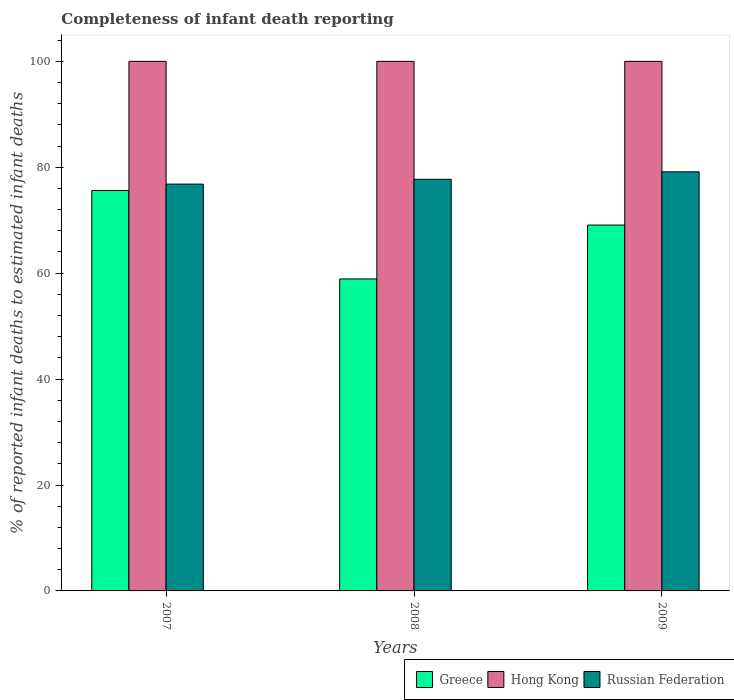How many different coloured bars are there?
Offer a very short reply. 3. What is the label of the 2nd group of bars from the left?
Give a very brief answer. 2008. Across all years, what is the maximum percentage of infant deaths reported in Russian Federation?
Give a very brief answer. 79.14. Across all years, what is the minimum percentage of infant deaths reported in Greece?
Your response must be concise. 58.91. In which year was the percentage of infant deaths reported in Hong Kong maximum?
Make the answer very short. 2007. In which year was the percentage of infant deaths reported in Greece minimum?
Make the answer very short. 2008. What is the total percentage of infant deaths reported in Greece in the graph?
Keep it short and to the point. 203.62. What is the difference between the percentage of infant deaths reported in Russian Federation in 2008 and the percentage of infant deaths reported in Hong Kong in 2009?
Make the answer very short. -22.27. In the year 2009, what is the difference between the percentage of infant deaths reported in Greece and percentage of infant deaths reported in Russian Federation?
Make the answer very short. -10.06. What is the ratio of the percentage of infant deaths reported in Hong Kong in 2007 to that in 2008?
Give a very brief answer. 1. What is the difference between the highest and the second highest percentage of infant deaths reported in Russian Federation?
Give a very brief answer. 1.41. What does the 3rd bar from the left in 2008 represents?
Offer a terse response. Russian Federation. What does the 2nd bar from the right in 2009 represents?
Keep it short and to the point. Hong Kong. How many bars are there?
Your answer should be compact. 9. Are all the bars in the graph horizontal?
Make the answer very short. No. Are the values on the major ticks of Y-axis written in scientific E-notation?
Give a very brief answer. No. Does the graph contain any zero values?
Offer a terse response. No. Does the graph contain grids?
Provide a short and direct response. No. How many legend labels are there?
Your answer should be compact. 3. What is the title of the graph?
Your response must be concise. Completeness of infant death reporting. What is the label or title of the X-axis?
Your answer should be very brief. Years. What is the label or title of the Y-axis?
Make the answer very short. % of reported infant deaths to estimated infant deaths. What is the % of reported infant deaths to estimated infant deaths in Greece in 2007?
Your response must be concise. 75.62. What is the % of reported infant deaths to estimated infant deaths in Russian Federation in 2007?
Keep it short and to the point. 76.82. What is the % of reported infant deaths to estimated infant deaths in Greece in 2008?
Ensure brevity in your answer.  58.91. What is the % of reported infant deaths to estimated infant deaths in Russian Federation in 2008?
Make the answer very short. 77.73. What is the % of reported infant deaths to estimated infant deaths in Greece in 2009?
Ensure brevity in your answer.  69.09. What is the % of reported infant deaths to estimated infant deaths of Russian Federation in 2009?
Make the answer very short. 79.14. Across all years, what is the maximum % of reported infant deaths to estimated infant deaths in Greece?
Provide a succinct answer. 75.62. Across all years, what is the maximum % of reported infant deaths to estimated infant deaths of Hong Kong?
Provide a short and direct response. 100. Across all years, what is the maximum % of reported infant deaths to estimated infant deaths in Russian Federation?
Keep it short and to the point. 79.14. Across all years, what is the minimum % of reported infant deaths to estimated infant deaths in Greece?
Your answer should be compact. 58.91. Across all years, what is the minimum % of reported infant deaths to estimated infant deaths in Hong Kong?
Offer a terse response. 100. Across all years, what is the minimum % of reported infant deaths to estimated infant deaths in Russian Federation?
Provide a short and direct response. 76.82. What is the total % of reported infant deaths to estimated infant deaths of Greece in the graph?
Ensure brevity in your answer.  203.62. What is the total % of reported infant deaths to estimated infant deaths of Hong Kong in the graph?
Provide a short and direct response. 300. What is the total % of reported infant deaths to estimated infant deaths in Russian Federation in the graph?
Your response must be concise. 233.69. What is the difference between the % of reported infant deaths to estimated infant deaths in Greece in 2007 and that in 2008?
Your answer should be very brief. 16.71. What is the difference between the % of reported infant deaths to estimated infant deaths in Hong Kong in 2007 and that in 2008?
Keep it short and to the point. 0. What is the difference between the % of reported infant deaths to estimated infant deaths of Russian Federation in 2007 and that in 2008?
Provide a short and direct response. -0.92. What is the difference between the % of reported infant deaths to estimated infant deaths of Greece in 2007 and that in 2009?
Your response must be concise. 6.53. What is the difference between the % of reported infant deaths to estimated infant deaths of Russian Federation in 2007 and that in 2009?
Make the answer very short. -2.33. What is the difference between the % of reported infant deaths to estimated infant deaths of Greece in 2008 and that in 2009?
Give a very brief answer. -10.18. What is the difference between the % of reported infant deaths to estimated infant deaths in Hong Kong in 2008 and that in 2009?
Your answer should be very brief. 0. What is the difference between the % of reported infant deaths to estimated infant deaths in Russian Federation in 2008 and that in 2009?
Offer a terse response. -1.41. What is the difference between the % of reported infant deaths to estimated infant deaths in Greece in 2007 and the % of reported infant deaths to estimated infant deaths in Hong Kong in 2008?
Keep it short and to the point. -24.38. What is the difference between the % of reported infant deaths to estimated infant deaths of Greece in 2007 and the % of reported infant deaths to estimated infant deaths of Russian Federation in 2008?
Your answer should be compact. -2.12. What is the difference between the % of reported infant deaths to estimated infant deaths in Hong Kong in 2007 and the % of reported infant deaths to estimated infant deaths in Russian Federation in 2008?
Provide a succinct answer. 22.27. What is the difference between the % of reported infant deaths to estimated infant deaths in Greece in 2007 and the % of reported infant deaths to estimated infant deaths in Hong Kong in 2009?
Provide a succinct answer. -24.38. What is the difference between the % of reported infant deaths to estimated infant deaths of Greece in 2007 and the % of reported infant deaths to estimated infant deaths of Russian Federation in 2009?
Provide a short and direct response. -3.52. What is the difference between the % of reported infant deaths to estimated infant deaths in Hong Kong in 2007 and the % of reported infant deaths to estimated infant deaths in Russian Federation in 2009?
Provide a short and direct response. 20.86. What is the difference between the % of reported infant deaths to estimated infant deaths of Greece in 2008 and the % of reported infant deaths to estimated infant deaths of Hong Kong in 2009?
Ensure brevity in your answer.  -41.09. What is the difference between the % of reported infant deaths to estimated infant deaths of Greece in 2008 and the % of reported infant deaths to estimated infant deaths of Russian Federation in 2009?
Your answer should be compact. -20.23. What is the difference between the % of reported infant deaths to estimated infant deaths of Hong Kong in 2008 and the % of reported infant deaths to estimated infant deaths of Russian Federation in 2009?
Keep it short and to the point. 20.86. What is the average % of reported infant deaths to estimated infant deaths of Greece per year?
Your answer should be very brief. 67.87. What is the average % of reported infant deaths to estimated infant deaths in Russian Federation per year?
Ensure brevity in your answer.  77.9. In the year 2007, what is the difference between the % of reported infant deaths to estimated infant deaths in Greece and % of reported infant deaths to estimated infant deaths in Hong Kong?
Your response must be concise. -24.38. In the year 2007, what is the difference between the % of reported infant deaths to estimated infant deaths in Greece and % of reported infant deaths to estimated infant deaths in Russian Federation?
Offer a terse response. -1.2. In the year 2007, what is the difference between the % of reported infant deaths to estimated infant deaths in Hong Kong and % of reported infant deaths to estimated infant deaths in Russian Federation?
Keep it short and to the point. 23.18. In the year 2008, what is the difference between the % of reported infant deaths to estimated infant deaths in Greece and % of reported infant deaths to estimated infant deaths in Hong Kong?
Keep it short and to the point. -41.09. In the year 2008, what is the difference between the % of reported infant deaths to estimated infant deaths in Greece and % of reported infant deaths to estimated infant deaths in Russian Federation?
Your answer should be compact. -18.82. In the year 2008, what is the difference between the % of reported infant deaths to estimated infant deaths of Hong Kong and % of reported infant deaths to estimated infant deaths of Russian Federation?
Offer a very short reply. 22.27. In the year 2009, what is the difference between the % of reported infant deaths to estimated infant deaths in Greece and % of reported infant deaths to estimated infant deaths in Hong Kong?
Your answer should be very brief. -30.91. In the year 2009, what is the difference between the % of reported infant deaths to estimated infant deaths of Greece and % of reported infant deaths to estimated infant deaths of Russian Federation?
Provide a succinct answer. -10.06. In the year 2009, what is the difference between the % of reported infant deaths to estimated infant deaths in Hong Kong and % of reported infant deaths to estimated infant deaths in Russian Federation?
Your answer should be compact. 20.86. What is the ratio of the % of reported infant deaths to estimated infant deaths of Greece in 2007 to that in 2008?
Keep it short and to the point. 1.28. What is the ratio of the % of reported infant deaths to estimated infant deaths of Hong Kong in 2007 to that in 2008?
Keep it short and to the point. 1. What is the ratio of the % of reported infant deaths to estimated infant deaths of Russian Federation in 2007 to that in 2008?
Your answer should be compact. 0.99. What is the ratio of the % of reported infant deaths to estimated infant deaths of Greece in 2007 to that in 2009?
Provide a succinct answer. 1.09. What is the ratio of the % of reported infant deaths to estimated infant deaths of Russian Federation in 2007 to that in 2009?
Offer a very short reply. 0.97. What is the ratio of the % of reported infant deaths to estimated infant deaths in Greece in 2008 to that in 2009?
Provide a succinct answer. 0.85. What is the ratio of the % of reported infant deaths to estimated infant deaths of Hong Kong in 2008 to that in 2009?
Ensure brevity in your answer.  1. What is the ratio of the % of reported infant deaths to estimated infant deaths in Russian Federation in 2008 to that in 2009?
Provide a short and direct response. 0.98. What is the difference between the highest and the second highest % of reported infant deaths to estimated infant deaths of Greece?
Your answer should be compact. 6.53. What is the difference between the highest and the second highest % of reported infant deaths to estimated infant deaths of Hong Kong?
Your answer should be very brief. 0. What is the difference between the highest and the second highest % of reported infant deaths to estimated infant deaths in Russian Federation?
Your answer should be very brief. 1.41. What is the difference between the highest and the lowest % of reported infant deaths to estimated infant deaths in Greece?
Your answer should be compact. 16.71. What is the difference between the highest and the lowest % of reported infant deaths to estimated infant deaths in Russian Federation?
Keep it short and to the point. 2.33. 